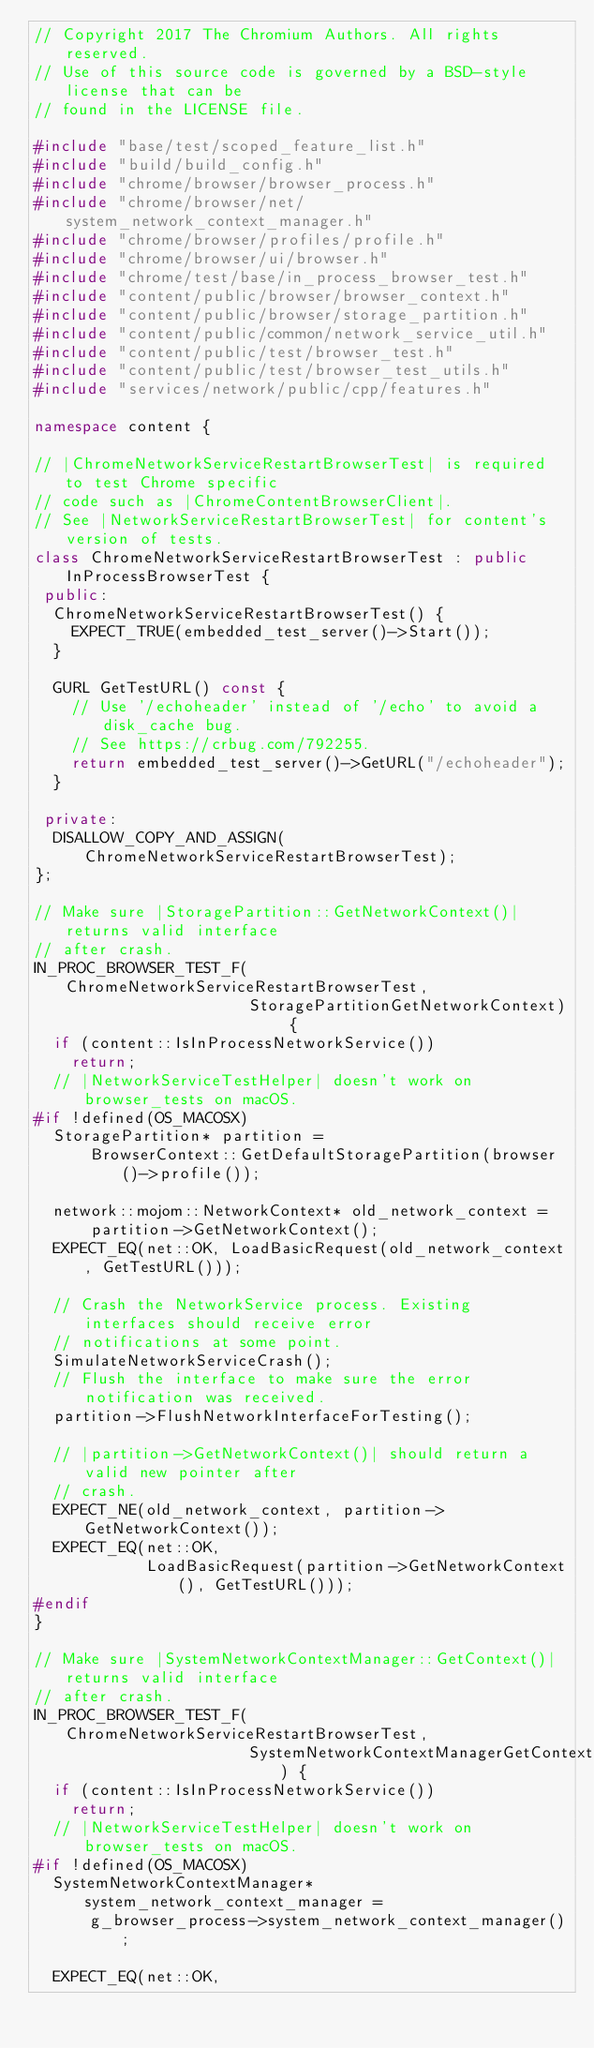Convert code to text. <code><loc_0><loc_0><loc_500><loc_500><_C++_>// Copyright 2017 The Chromium Authors. All rights reserved.
// Use of this source code is governed by a BSD-style license that can be
// found in the LICENSE file.

#include "base/test/scoped_feature_list.h"
#include "build/build_config.h"
#include "chrome/browser/browser_process.h"
#include "chrome/browser/net/system_network_context_manager.h"
#include "chrome/browser/profiles/profile.h"
#include "chrome/browser/ui/browser.h"
#include "chrome/test/base/in_process_browser_test.h"
#include "content/public/browser/browser_context.h"
#include "content/public/browser/storage_partition.h"
#include "content/public/common/network_service_util.h"
#include "content/public/test/browser_test.h"
#include "content/public/test/browser_test_utils.h"
#include "services/network/public/cpp/features.h"

namespace content {

// |ChromeNetworkServiceRestartBrowserTest| is required to test Chrome specific
// code such as |ChromeContentBrowserClient|.
// See |NetworkServiceRestartBrowserTest| for content's version of tests.
class ChromeNetworkServiceRestartBrowserTest : public InProcessBrowserTest {
 public:
  ChromeNetworkServiceRestartBrowserTest() {
    EXPECT_TRUE(embedded_test_server()->Start());
  }

  GURL GetTestURL() const {
    // Use '/echoheader' instead of '/echo' to avoid a disk_cache bug.
    // See https://crbug.com/792255.
    return embedded_test_server()->GetURL("/echoheader");
  }

 private:
  DISALLOW_COPY_AND_ASSIGN(ChromeNetworkServiceRestartBrowserTest);
};

// Make sure |StoragePartition::GetNetworkContext()| returns valid interface
// after crash.
IN_PROC_BROWSER_TEST_F(ChromeNetworkServiceRestartBrowserTest,
                       StoragePartitionGetNetworkContext) {
  if (content::IsInProcessNetworkService())
    return;
  // |NetworkServiceTestHelper| doesn't work on browser_tests on macOS.
#if !defined(OS_MACOSX)
  StoragePartition* partition =
      BrowserContext::GetDefaultStoragePartition(browser()->profile());

  network::mojom::NetworkContext* old_network_context =
      partition->GetNetworkContext();
  EXPECT_EQ(net::OK, LoadBasicRequest(old_network_context, GetTestURL()));

  // Crash the NetworkService process. Existing interfaces should receive error
  // notifications at some point.
  SimulateNetworkServiceCrash();
  // Flush the interface to make sure the error notification was received.
  partition->FlushNetworkInterfaceForTesting();

  // |partition->GetNetworkContext()| should return a valid new pointer after
  // crash.
  EXPECT_NE(old_network_context, partition->GetNetworkContext());
  EXPECT_EQ(net::OK,
            LoadBasicRequest(partition->GetNetworkContext(), GetTestURL()));
#endif
}

// Make sure |SystemNetworkContextManager::GetContext()| returns valid interface
// after crash.
IN_PROC_BROWSER_TEST_F(ChromeNetworkServiceRestartBrowserTest,
                       SystemNetworkContextManagerGetContext) {
  if (content::IsInProcessNetworkService())
    return;
  // |NetworkServiceTestHelper| doesn't work on browser_tests on macOS.
#if !defined(OS_MACOSX)
  SystemNetworkContextManager* system_network_context_manager =
      g_browser_process->system_network_context_manager();

  EXPECT_EQ(net::OK,</code> 